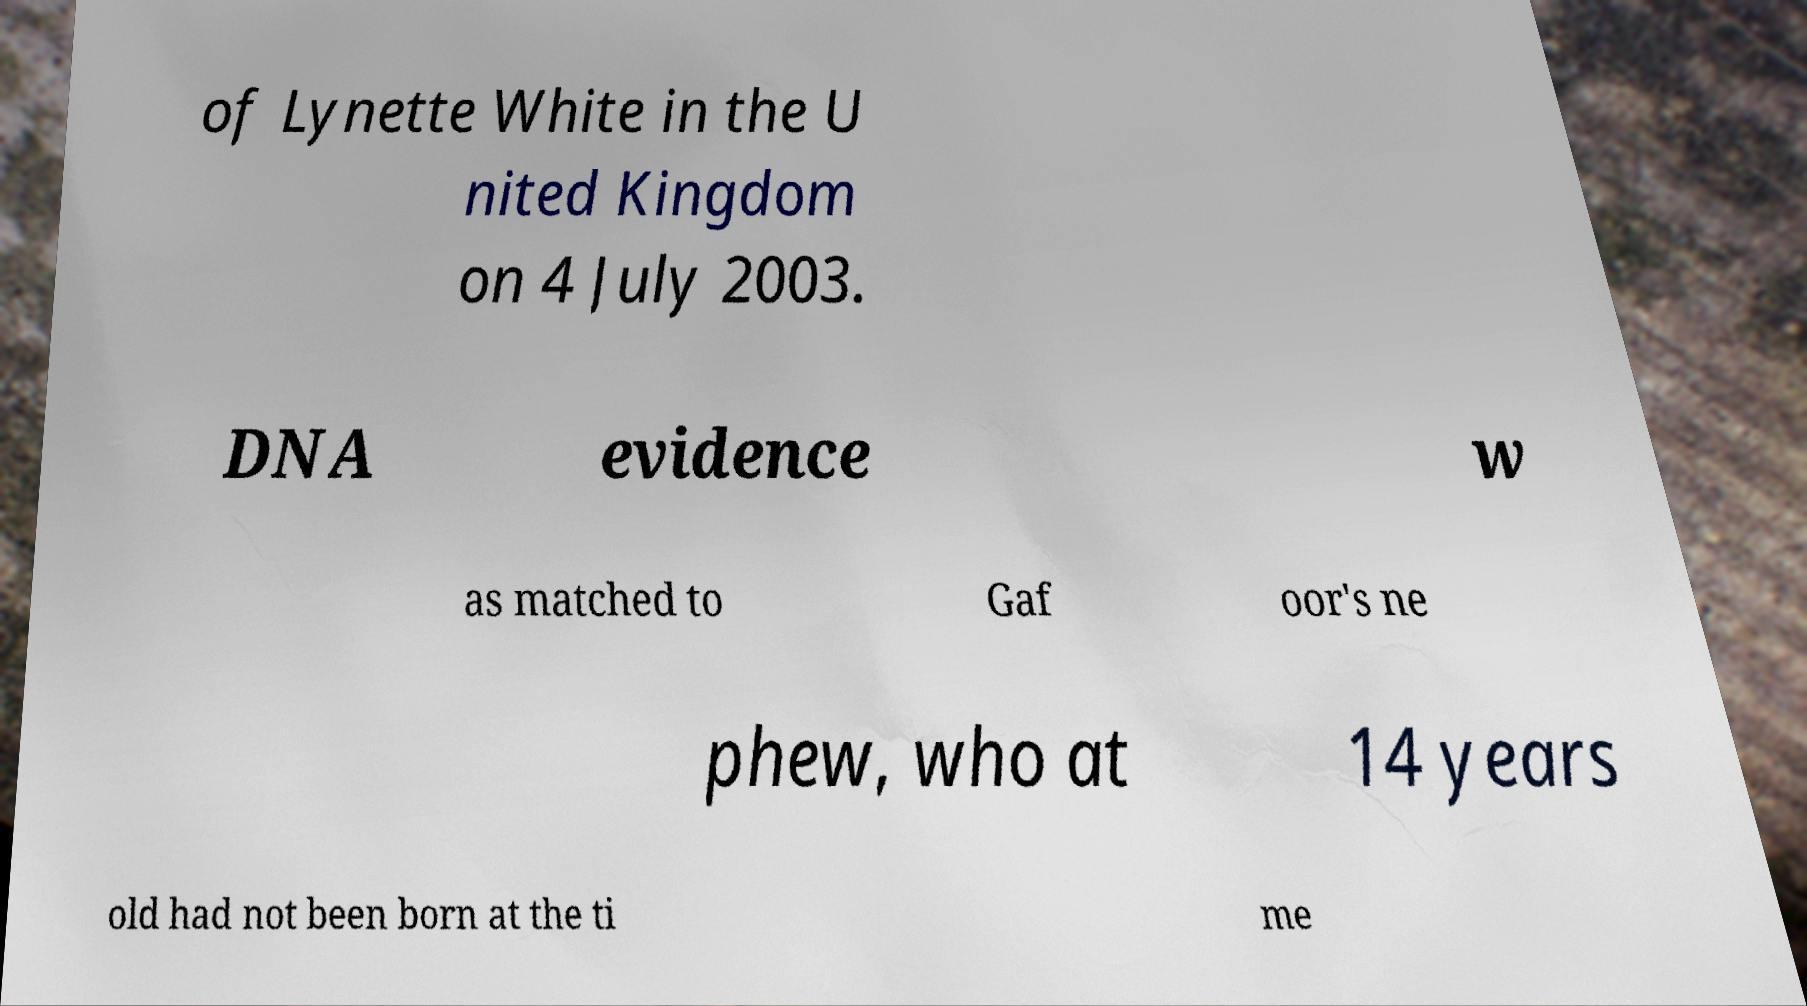Please identify and transcribe the text found in this image. of Lynette White in the U nited Kingdom on 4 July 2003. DNA evidence w as matched to Gaf oor's ne phew, who at 14 years old had not been born at the ti me 